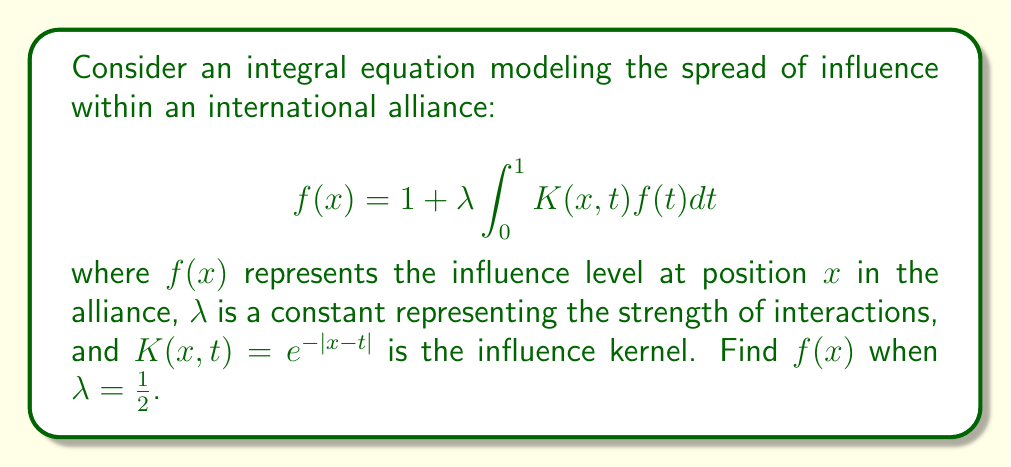Can you answer this question? 1) We start by assuming a solution of the form $f(x) = a + bx$, where $a$ and $b$ are constants to be determined.

2) Substituting this into the integral equation:

   $$a + bx = 1 + \frac{1}{2} \int_0^1 e^{-|x-t|}(a + bt)dt$$

3) Let's evaluate the integral:

   $$\int_0^1 e^{-|x-t|}dt = \int_0^x e^{-(x-t)}dt + \int_x^1 e^{-(t-x)}dt$$
   $$= [-e^{-(x-t)}]_0^x + [e^{-(t-x)}]_x^1$$
   $$= (1-e^{-x}) + (e^{-(1-x)}-1) = 2 - e^{-x} - e^{-(1-x)}$$

   $$\int_0^1 e^{-|x-t|}t dt = \int_0^x e^{-(x-t)}t dt + \int_x^1 e^{-(t-x)}t dt$$
   $$= [te^{-(x-t)}]_0^x - \int_0^x e^{-(x-t)}dt + [te^{-(t-x)}]_x^1 + \int_x^1 e^{-(t-x)}dt$$
   $$= xe^0 - (1-e^{-x}) + e^{-(1-x)} - xe^0 + (e^{-(1-x)}-1)$$
   $$= 2e^{-(1-x)} - e^{-x} - 1$$

4) Substituting these results back into the equation:

   $$a + bx = 1 + \frac{1}{2}a(2 - e^{-x} - e^{-(1-x)}) + \frac{1}{2}b(2e^{-(1-x)} - e^{-x} - 1)$$

5) Equating coefficients of $x$ and constant terms:

   Constant terms: $a = 1 + a - \frac{1}{2}ae^{-1} - \frac{1}{2}ae^{-1} - \frac{1}{2}b$
   
   $x$ terms: $b = -\frac{1}{2}ae^{-1} + \frac{1}{2}ae^{-1} + be^{-1}$

6) From the $x$ terms equation: $b(1-e^{-1}) = 0$, so $b = 0$.

7) Substituting $b=0$ into the constant terms equation:

   $a = 1 + a - ae^{-1}$
   $ae^{-1} = 1$
   $a = e$

8) Therefore, the solution is $f(x) = e$.
Answer: $f(x) = e$ 